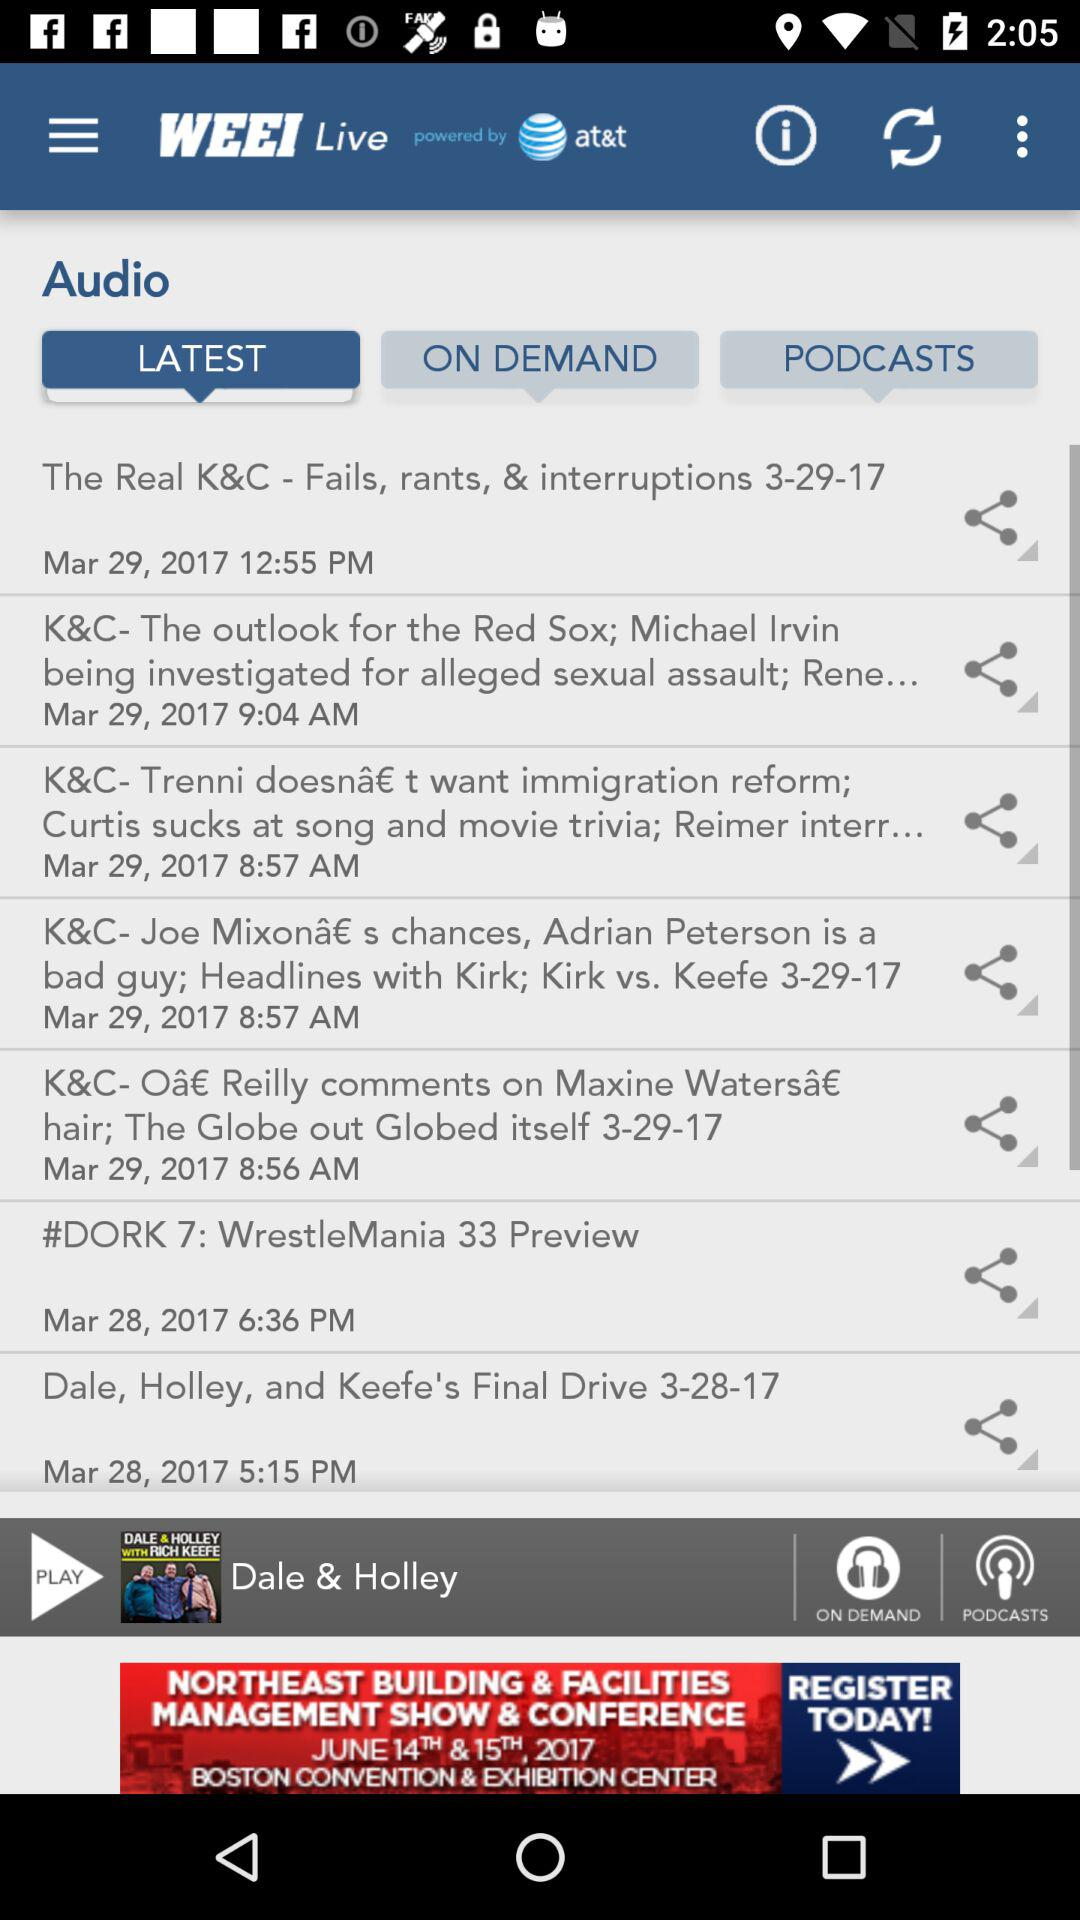Which tab has been selected? The selected tab is "LATEST". 